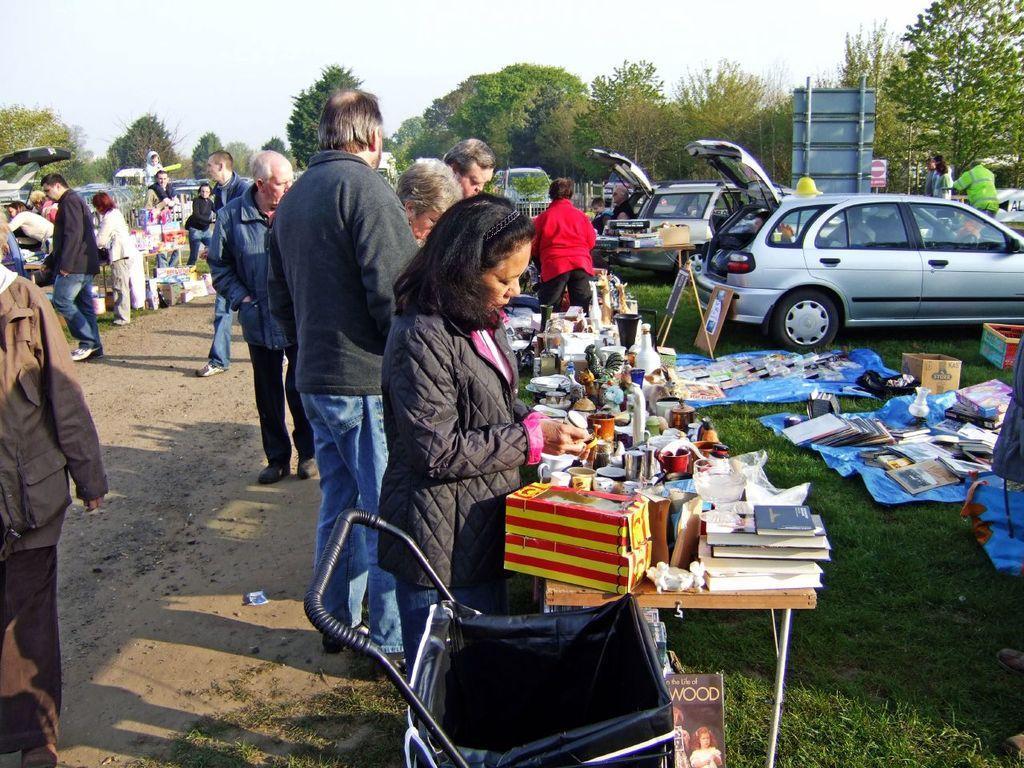How would you summarize this image in a sentence or two? In this picture we can see a group of people on the ground, grass, cart, posters, books, boxes, vehicles, trees, some objects and in the background we can see the sky. 